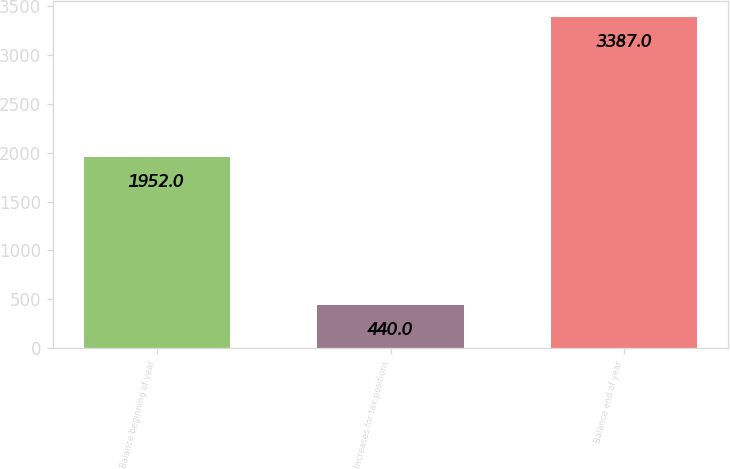<chart> <loc_0><loc_0><loc_500><loc_500><bar_chart><fcel>Balance beginning of year<fcel>Increases for tax positions<fcel>Balance end of year<nl><fcel>1952<fcel>440<fcel>3387<nl></chart> 